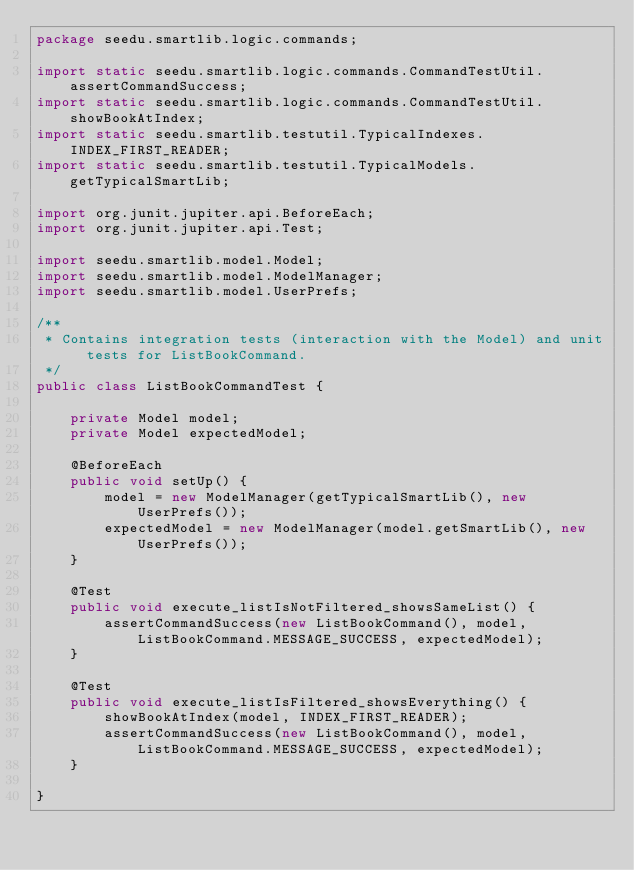<code> <loc_0><loc_0><loc_500><loc_500><_Java_>package seedu.smartlib.logic.commands;

import static seedu.smartlib.logic.commands.CommandTestUtil.assertCommandSuccess;
import static seedu.smartlib.logic.commands.CommandTestUtil.showBookAtIndex;
import static seedu.smartlib.testutil.TypicalIndexes.INDEX_FIRST_READER;
import static seedu.smartlib.testutil.TypicalModels.getTypicalSmartLib;

import org.junit.jupiter.api.BeforeEach;
import org.junit.jupiter.api.Test;

import seedu.smartlib.model.Model;
import seedu.smartlib.model.ModelManager;
import seedu.smartlib.model.UserPrefs;

/**
 * Contains integration tests (interaction with the Model) and unit tests for ListBookCommand.
 */
public class ListBookCommandTest {

    private Model model;
    private Model expectedModel;

    @BeforeEach
    public void setUp() {
        model = new ModelManager(getTypicalSmartLib(), new UserPrefs());
        expectedModel = new ModelManager(model.getSmartLib(), new UserPrefs());
    }

    @Test
    public void execute_listIsNotFiltered_showsSameList() {
        assertCommandSuccess(new ListBookCommand(), model, ListBookCommand.MESSAGE_SUCCESS, expectedModel);
    }

    @Test
    public void execute_listIsFiltered_showsEverything() {
        showBookAtIndex(model, INDEX_FIRST_READER);
        assertCommandSuccess(new ListBookCommand(), model, ListBookCommand.MESSAGE_SUCCESS, expectedModel);
    }

}
</code> 